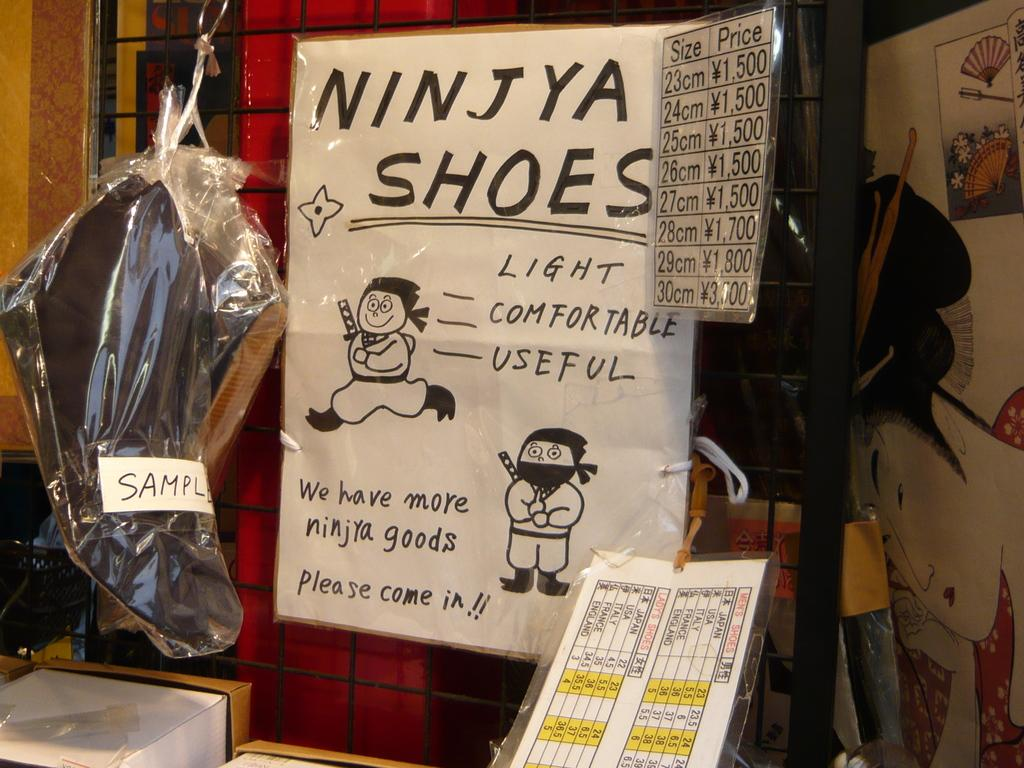<image>
Give a short and clear explanation of the subsequent image. A hand written sign in plastic wrap says Ninjya Shoes. 